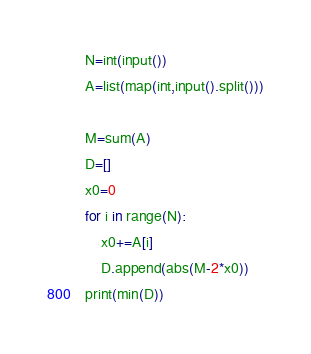<code> <loc_0><loc_0><loc_500><loc_500><_Python_>N=int(input())
A=list(map(int,input().split()))

M=sum(A)
D=[]
x0=0
for i in range(N):
    x0+=A[i]
    D.append(abs(M-2*x0))
print(min(D))</code> 